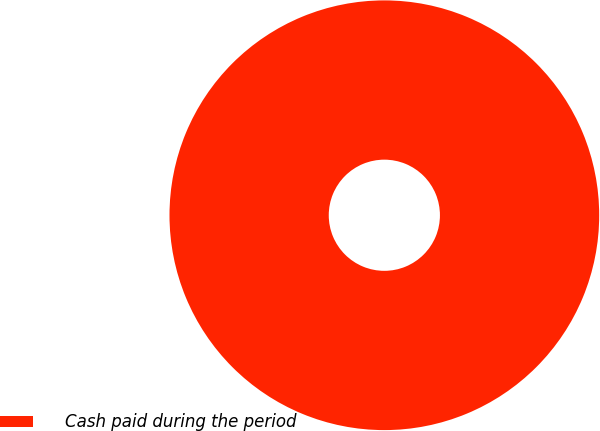<chart> <loc_0><loc_0><loc_500><loc_500><pie_chart><fcel>Cash paid during the period<nl><fcel>100.0%<nl></chart> 